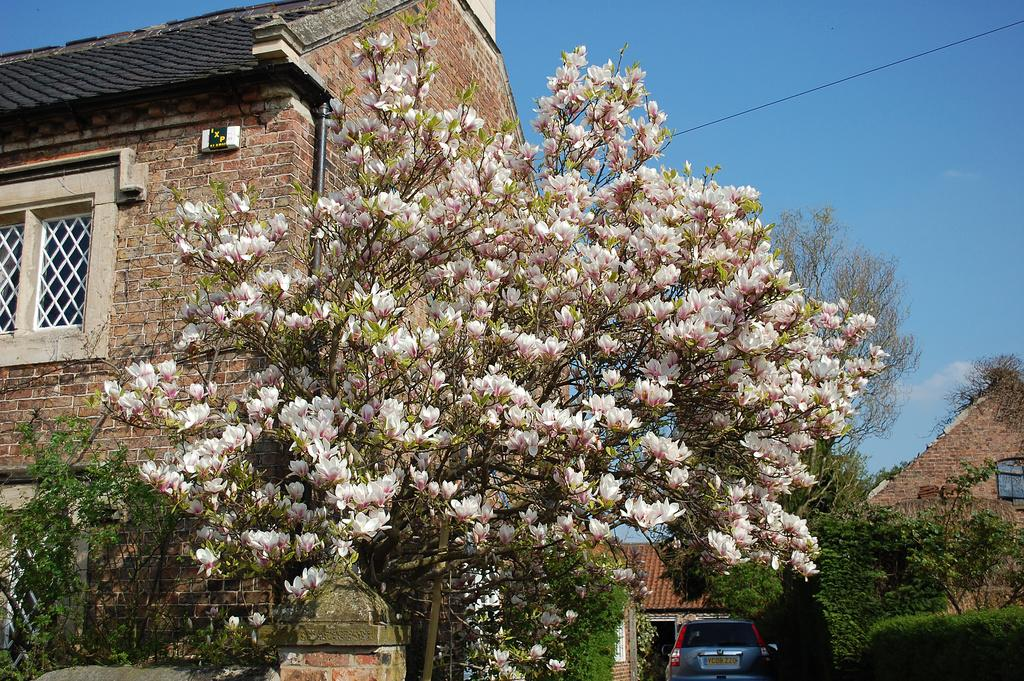What is the main subject in the center of the image? There is a tree with flowers in the center of the image. What can be seen in the background of the image? There is a house and the sky visible in the background of the image. What is located at the bottom of the image? There is a car at the bottom of the image. What type of fuel is being used by the tree in the image? Trees do not use fuel; they produce their own energy through photosynthesis. 